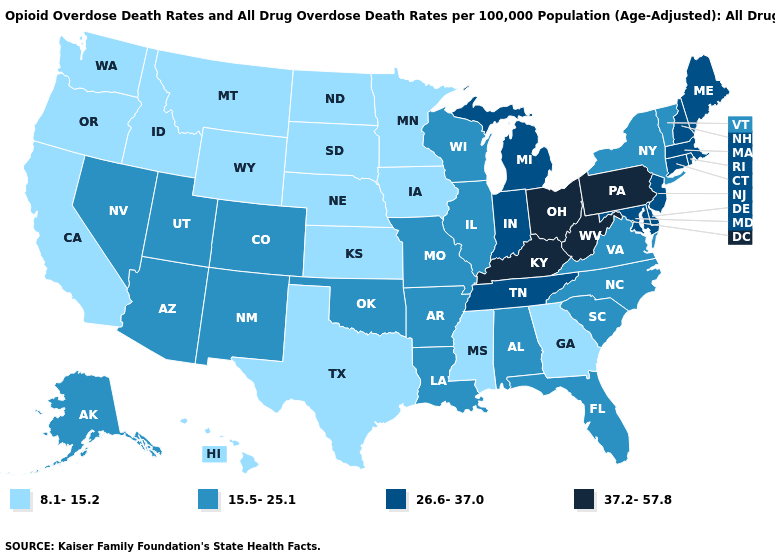Name the states that have a value in the range 8.1-15.2?
Short answer required. California, Georgia, Hawaii, Idaho, Iowa, Kansas, Minnesota, Mississippi, Montana, Nebraska, North Dakota, Oregon, South Dakota, Texas, Washington, Wyoming. Which states have the highest value in the USA?
Give a very brief answer. Kentucky, Ohio, Pennsylvania, West Virginia. Which states have the lowest value in the South?
Short answer required. Georgia, Mississippi, Texas. Name the states that have a value in the range 37.2-57.8?
Concise answer only. Kentucky, Ohio, Pennsylvania, West Virginia. Name the states that have a value in the range 15.5-25.1?
Quick response, please. Alabama, Alaska, Arizona, Arkansas, Colorado, Florida, Illinois, Louisiana, Missouri, Nevada, New Mexico, New York, North Carolina, Oklahoma, South Carolina, Utah, Vermont, Virginia, Wisconsin. Does the first symbol in the legend represent the smallest category?
Short answer required. Yes. Does Kansas have the lowest value in the USA?
Short answer required. Yes. What is the value of Utah?
Short answer required. 15.5-25.1. Name the states that have a value in the range 15.5-25.1?
Be succinct. Alabama, Alaska, Arizona, Arkansas, Colorado, Florida, Illinois, Louisiana, Missouri, Nevada, New Mexico, New York, North Carolina, Oklahoma, South Carolina, Utah, Vermont, Virginia, Wisconsin. What is the value of West Virginia?
Give a very brief answer. 37.2-57.8. What is the lowest value in the USA?
Write a very short answer. 8.1-15.2. Name the states that have a value in the range 15.5-25.1?
Write a very short answer. Alabama, Alaska, Arizona, Arkansas, Colorado, Florida, Illinois, Louisiana, Missouri, Nevada, New Mexico, New York, North Carolina, Oklahoma, South Carolina, Utah, Vermont, Virginia, Wisconsin. What is the value of Arizona?
Short answer required. 15.5-25.1. Does the map have missing data?
Be succinct. No. What is the value of Montana?
Answer briefly. 8.1-15.2. 